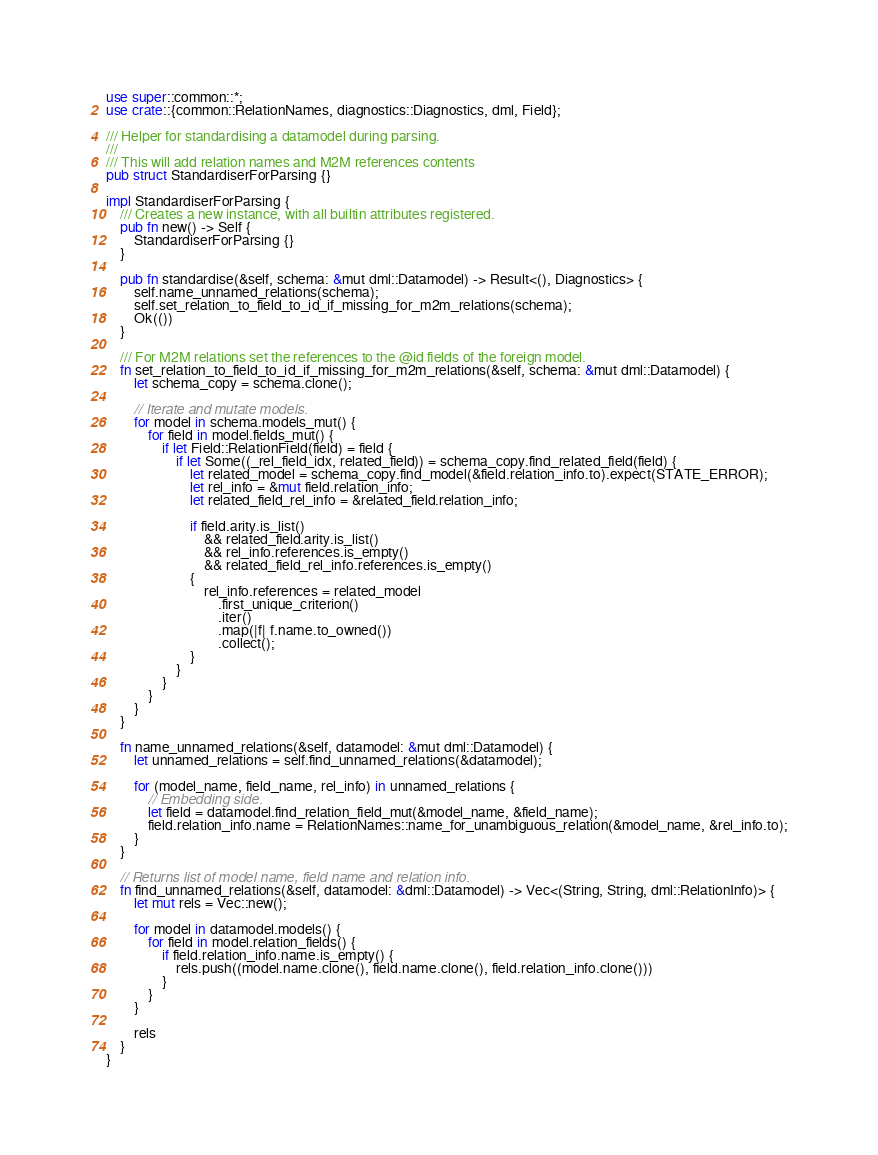<code> <loc_0><loc_0><loc_500><loc_500><_Rust_>use super::common::*;
use crate::{common::RelationNames, diagnostics::Diagnostics, dml, Field};

/// Helper for standardising a datamodel during parsing.
///
/// This will add relation names and M2M references contents
pub struct StandardiserForParsing {}

impl StandardiserForParsing {
    /// Creates a new instance, with all builtin attributes registered.
    pub fn new() -> Self {
        StandardiserForParsing {}
    }

    pub fn standardise(&self, schema: &mut dml::Datamodel) -> Result<(), Diagnostics> {
        self.name_unnamed_relations(schema);
        self.set_relation_to_field_to_id_if_missing_for_m2m_relations(schema);
        Ok(())
    }

    /// For M2M relations set the references to the @id fields of the foreign model.
    fn set_relation_to_field_to_id_if_missing_for_m2m_relations(&self, schema: &mut dml::Datamodel) {
        let schema_copy = schema.clone();

        // Iterate and mutate models.
        for model in schema.models_mut() {
            for field in model.fields_mut() {
                if let Field::RelationField(field) = field {
                    if let Some((_rel_field_idx, related_field)) = schema_copy.find_related_field(field) {
                        let related_model = schema_copy.find_model(&field.relation_info.to).expect(STATE_ERROR);
                        let rel_info = &mut field.relation_info;
                        let related_field_rel_info = &related_field.relation_info;

                        if field.arity.is_list()
                            && related_field.arity.is_list()
                            && rel_info.references.is_empty()
                            && related_field_rel_info.references.is_empty()
                        {
                            rel_info.references = related_model
                                .first_unique_criterion()
                                .iter()
                                .map(|f| f.name.to_owned())
                                .collect();
                        }
                    }
                }
            }
        }
    }

    fn name_unnamed_relations(&self, datamodel: &mut dml::Datamodel) {
        let unnamed_relations = self.find_unnamed_relations(&datamodel);

        for (model_name, field_name, rel_info) in unnamed_relations {
            // Embedding side.
            let field = datamodel.find_relation_field_mut(&model_name, &field_name);
            field.relation_info.name = RelationNames::name_for_unambiguous_relation(&model_name, &rel_info.to);
        }
    }

    // Returns list of model name, field name and relation info.
    fn find_unnamed_relations(&self, datamodel: &dml::Datamodel) -> Vec<(String, String, dml::RelationInfo)> {
        let mut rels = Vec::new();

        for model in datamodel.models() {
            for field in model.relation_fields() {
                if field.relation_info.name.is_empty() {
                    rels.push((model.name.clone(), field.name.clone(), field.relation_info.clone()))
                }
            }
        }

        rels
    }
}
</code> 